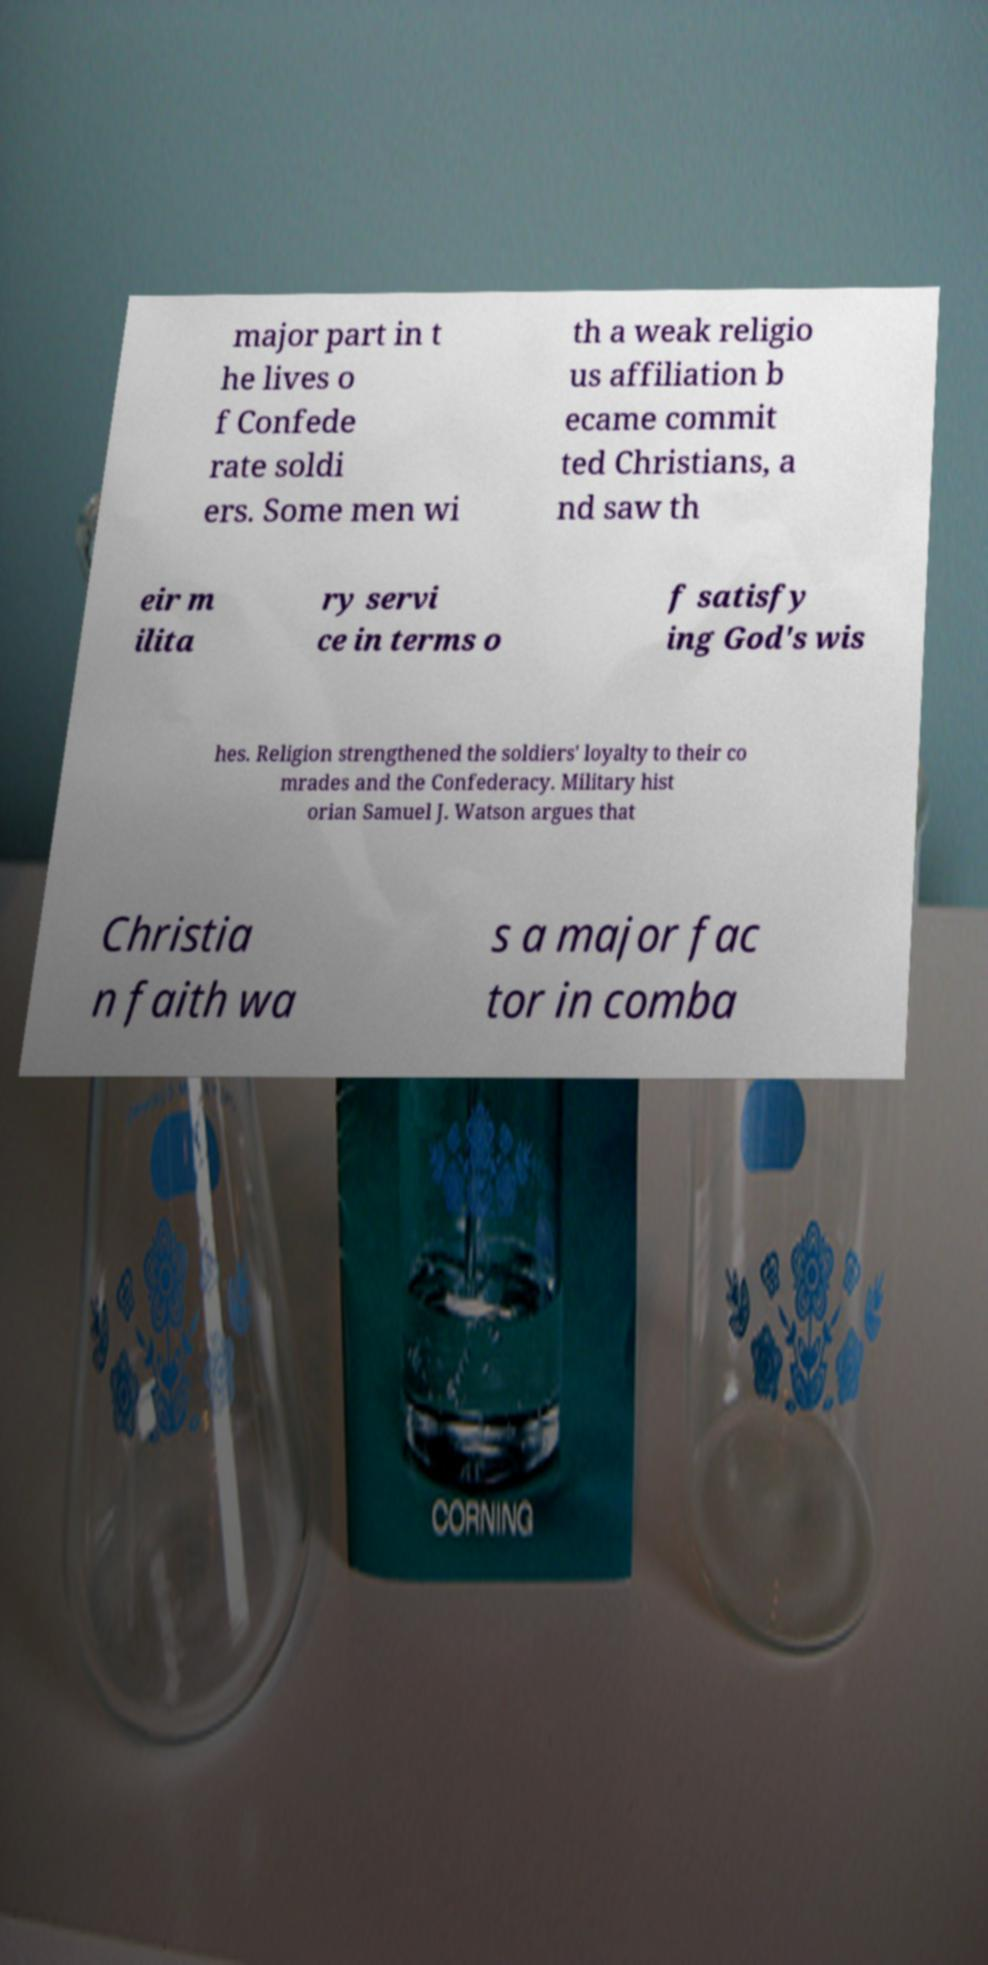Please identify and transcribe the text found in this image. major part in t he lives o f Confede rate soldi ers. Some men wi th a weak religio us affiliation b ecame commit ted Christians, a nd saw th eir m ilita ry servi ce in terms o f satisfy ing God's wis hes. Religion strengthened the soldiers' loyalty to their co mrades and the Confederacy. Military hist orian Samuel J. Watson argues that Christia n faith wa s a major fac tor in comba 